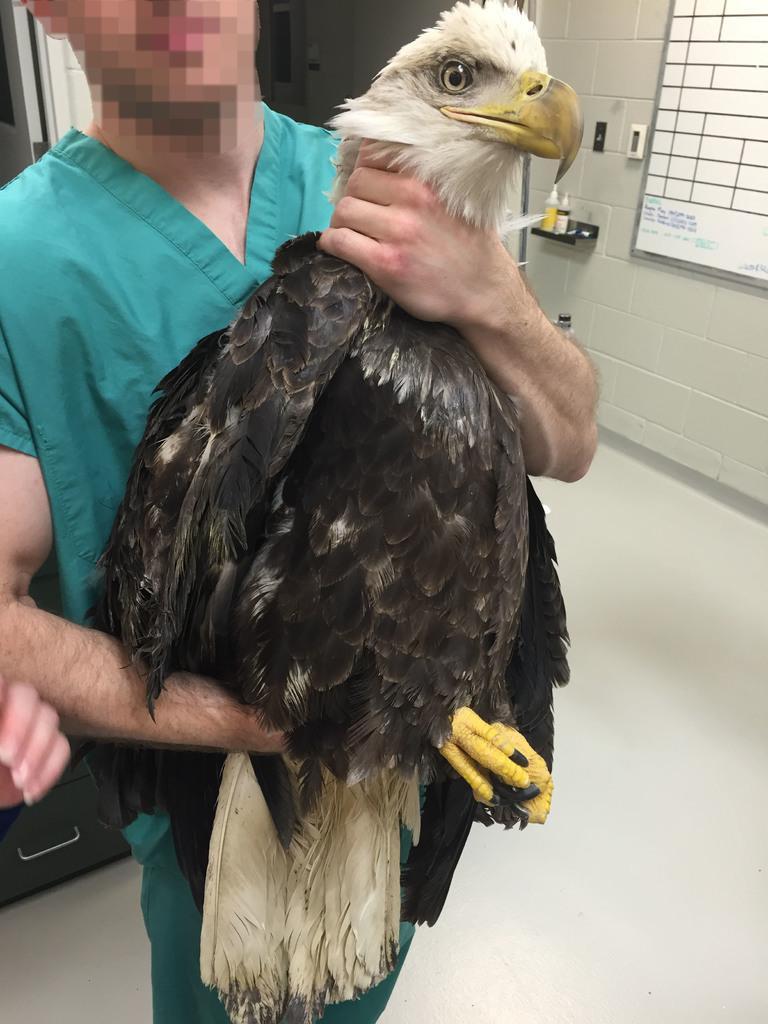What is present in the image? There is a person in the image. What is the person wearing? The person is wearing clothes. What is the person holding in their hand? The person is holding an eagle in their hand. What architectural features can be seen in the image? There is a window and a wall in the image. What type of surface is visible in the image? The surface is white in color. Can you identify any body parts of the person in the image? Yes, there is a human hand visible in the image. What type of basket is being blown by the needle in the image? There is no basket, blowing, or needle present in the image. 